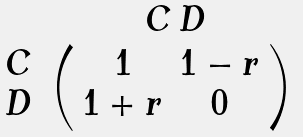<formula> <loc_0><loc_0><loc_500><loc_500>\begin{array} { c } \\ C \\ D \end{array} \begin{array} { c } \, C \, D \\ \left ( \begin{array} { c c } 1 & 1 - r \\ 1 + r & 0 \end{array} \right ) \end{array}</formula> 